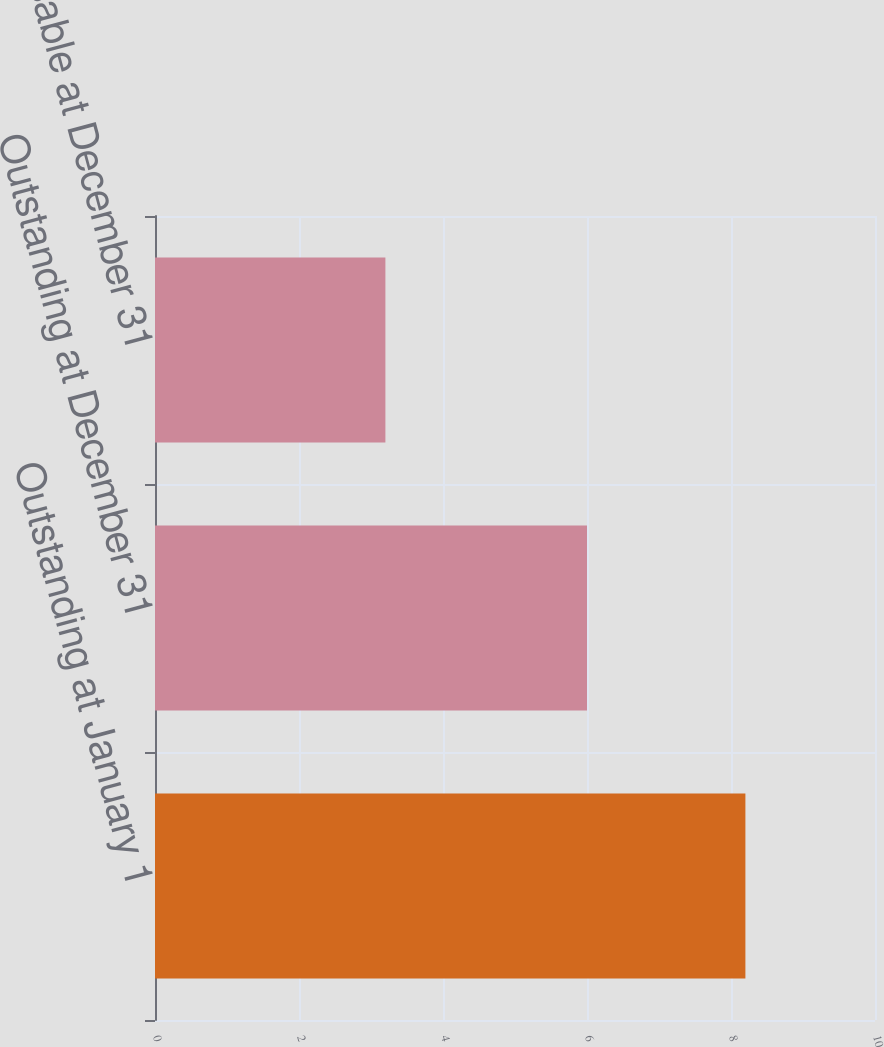Convert chart to OTSL. <chart><loc_0><loc_0><loc_500><loc_500><bar_chart><fcel>Outstanding at January 1<fcel>Outstanding at December 31<fcel>Exercisable at December 31<nl><fcel>8.2<fcel>6<fcel>3.2<nl></chart> 